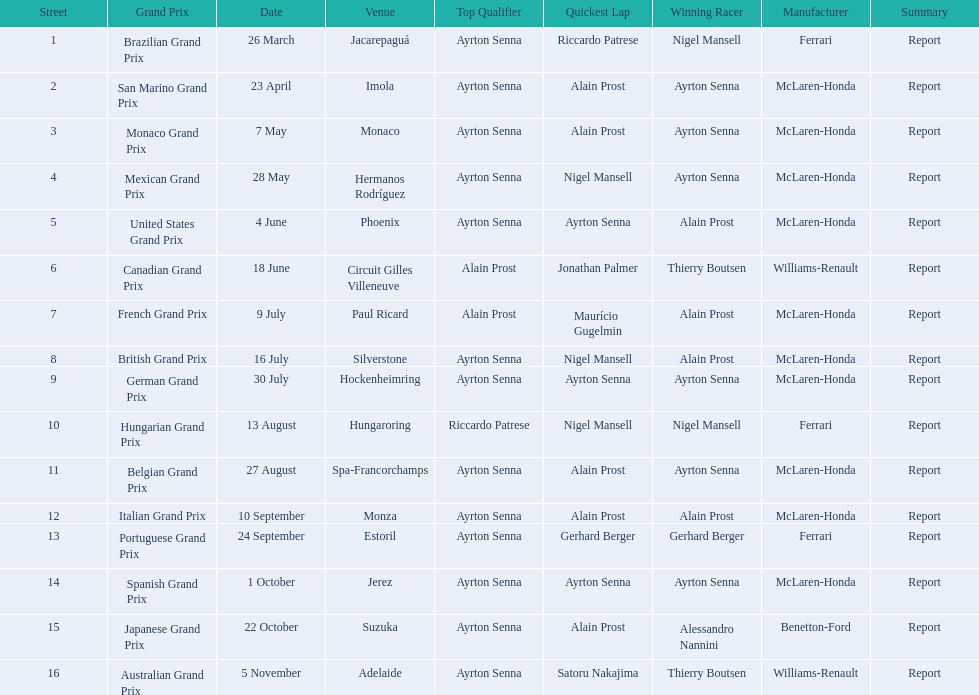How many times was ayrton senna in pole position? 13. 